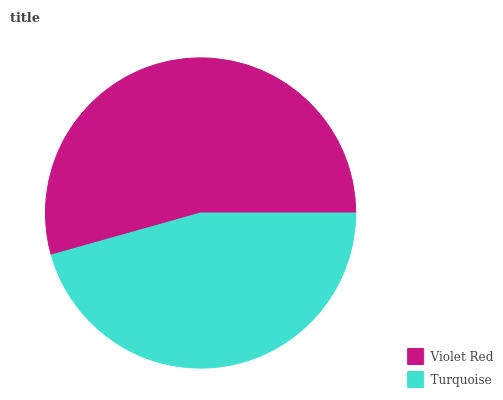Is Turquoise the minimum?
Answer yes or no. Yes. Is Violet Red the maximum?
Answer yes or no. Yes. Is Turquoise the maximum?
Answer yes or no. No. Is Violet Red greater than Turquoise?
Answer yes or no. Yes. Is Turquoise less than Violet Red?
Answer yes or no. Yes. Is Turquoise greater than Violet Red?
Answer yes or no. No. Is Violet Red less than Turquoise?
Answer yes or no. No. Is Violet Red the high median?
Answer yes or no. Yes. Is Turquoise the low median?
Answer yes or no. Yes. Is Turquoise the high median?
Answer yes or no. No. Is Violet Red the low median?
Answer yes or no. No. 